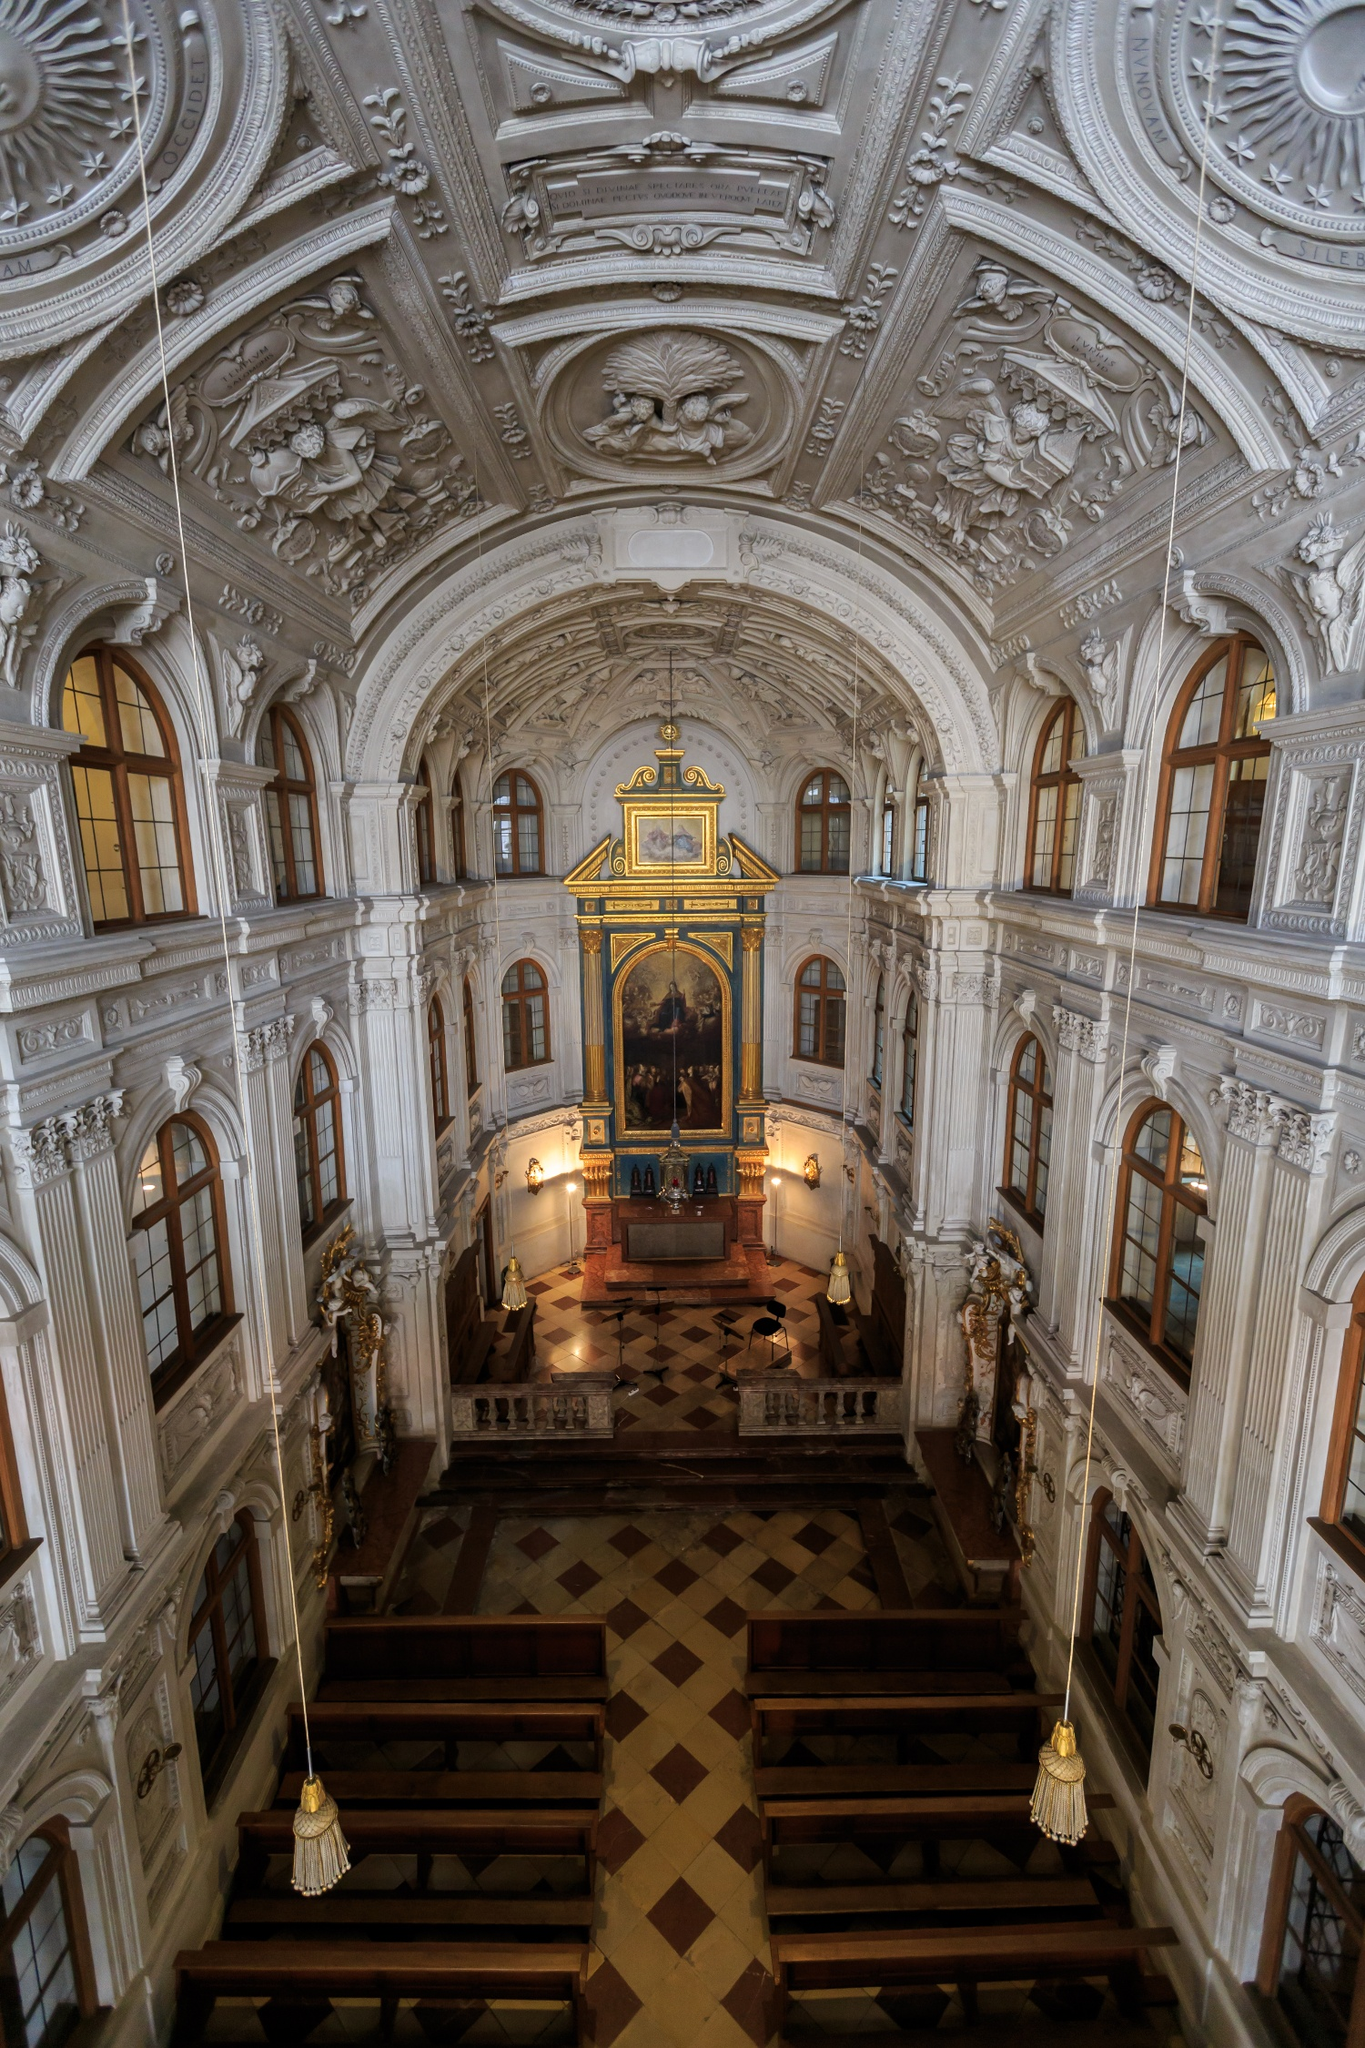As an explorer, what hidden secrets might you discover in this church? As an explorer, venturing into the depths of the Hofkirche, you might stumble upon hidden chambers used by royal families for secret meetings. Behind the majestic altar, perhaps there are concealed passages that once allowed clergy to move unseen during times of political intrigue. In the crypt, beyond the interred remains of royalty, maybe there lies an ancient relic or a forgotten manuscript containing clues to long-lost baroque rites. The intricate designs of the stucco work might hide symbols and codes waiting to be deciphered, revealing stories embedded not just in history books but in the very fabric of the church's walls. 